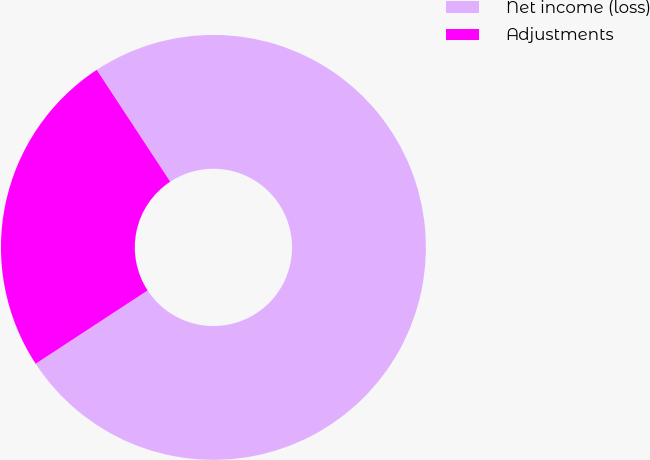<chart> <loc_0><loc_0><loc_500><loc_500><pie_chart><fcel>Net income (loss)<fcel>Adjustments<nl><fcel>75.03%<fcel>24.97%<nl></chart> 